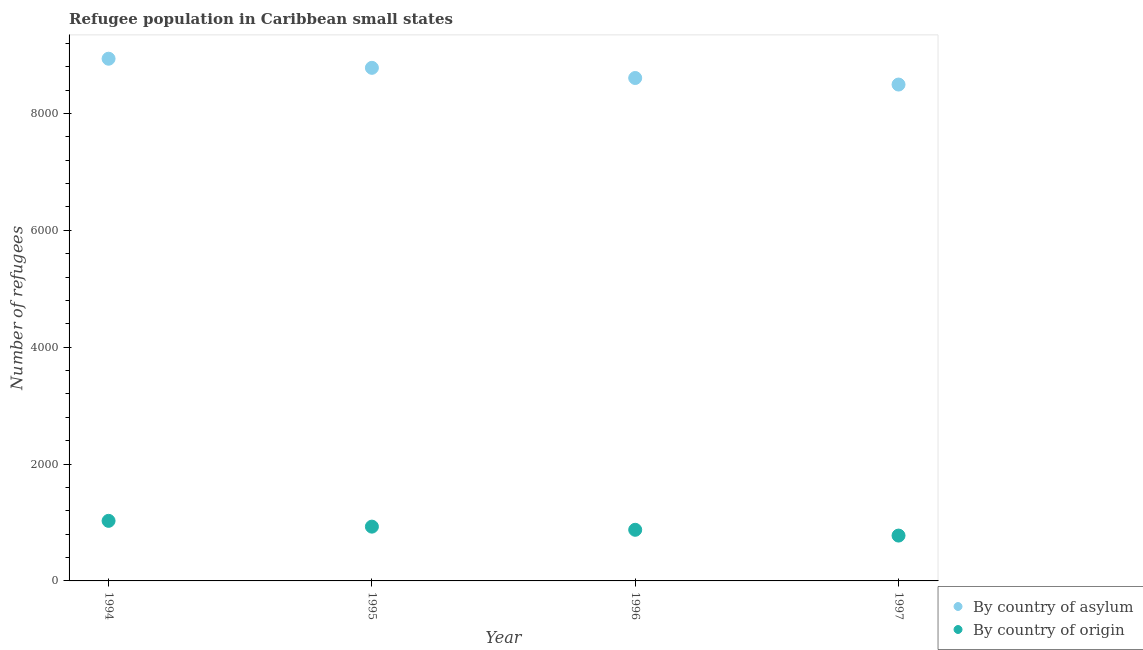What is the number of refugees by country of asylum in 1994?
Your answer should be very brief. 8937. Across all years, what is the maximum number of refugees by country of origin?
Your response must be concise. 1028. Across all years, what is the minimum number of refugees by country of asylum?
Offer a terse response. 8495. In which year was the number of refugees by country of asylum maximum?
Your answer should be very brief. 1994. What is the total number of refugees by country of asylum in the graph?
Provide a short and direct response. 3.48e+04. What is the difference between the number of refugees by country of origin in 1994 and that in 1997?
Give a very brief answer. 252. What is the difference between the number of refugees by country of asylum in 1996 and the number of refugees by country of origin in 1995?
Provide a succinct answer. 7678. What is the average number of refugees by country of asylum per year?
Offer a terse response. 8705. In the year 1994, what is the difference between the number of refugees by country of origin and number of refugees by country of asylum?
Offer a very short reply. -7909. In how many years, is the number of refugees by country of asylum greater than 4000?
Offer a terse response. 4. What is the ratio of the number of refugees by country of origin in 1994 to that in 1995?
Offer a very short reply. 1.11. Is the number of refugees by country of asylum in 1995 less than that in 1997?
Your response must be concise. No. Is the difference between the number of refugees by country of origin in 1994 and 1996 greater than the difference between the number of refugees by country of asylum in 1994 and 1996?
Your answer should be compact. No. What is the difference between the highest and the lowest number of refugees by country of origin?
Your answer should be very brief. 252. In how many years, is the number of refugees by country of origin greater than the average number of refugees by country of origin taken over all years?
Keep it short and to the point. 2. Is the number of refugees by country of origin strictly less than the number of refugees by country of asylum over the years?
Provide a succinct answer. Yes. How many years are there in the graph?
Your answer should be compact. 4. What is the difference between two consecutive major ticks on the Y-axis?
Your answer should be compact. 2000. Does the graph contain grids?
Your response must be concise. No. Where does the legend appear in the graph?
Give a very brief answer. Bottom right. What is the title of the graph?
Provide a short and direct response. Refugee population in Caribbean small states. What is the label or title of the Y-axis?
Offer a terse response. Number of refugees. What is the Number of refugees in By country of asylum in 1994?
Provide a short and direct response. 8937. What is the Number of refugees in By country of origin in 1994?
Your response must be concise. 1028. What is the Number of refugees of By country of asylum in 1995?
Keep it short and to the point. 8781. What is the Number of refugees in By country of origin in 1995?
Give a very brief answer. 929. What is the Number of refugees of By country of asylum in 1996?
Provide a succinct answer. 8607. What is the Number of refugees of By country of origin in 1996?
Ensure brevity in your answer.  875. What is the Number of refugees in By country of asylum in 1997?
Ensure brevity in your answer.  8495. What is the Number of refugees of By country of origin in 1997?
Your answer should be compact. 776. Across all years, what is the maximum Number of refugees of By country of asylum?
Your response must be concise. 8937. Across all years, what is the maximum Number of refugees of By country of origin?
Ensure brevity in your answer.  1028. Across all years, what is the minimum Number of refugees of By country of asylum?
Give a very brief answer. 8495. Across all years, what is the minimum Number of refugees in By country of origin?
Your answer should be very brief. 776. What is the total Number of refugees of By country of asylum in the graph?
Make the answer very short. 3.48e+04. What is the total Number of refugees of By country of origin in the graph?
Give a very brief answer. 3608. What is the difference between the Number of refugees of By country of asylum in 1994 and that in 1995?
Your answer should be compact. 156. What is the difference between the Number of refugees in By country of origin in 1994 and that in 1995?
Ensure brevity in your answer.  99. What is the difference between the Number of refugees of By country of asylum in 1994 and that in 1996?
Offer a very short reply. 330. What is the difference between the Number of refugees of By country of origin in 1994 and that in 1996?
Provide a short and direct response. 153. What is the difference between the Number of refugees of By country of asylum in 1994 and that in 1997?
Make the answer very short. 442. What is the difference between the Number of refugees in By country of origin in 1994 and that in 1997?
Make the answer very short. 252. What is the difference between the Number of refugees of By country of asylum in 1995 and that in 1996?
Make the answer very short. 174. What is the difference between the Number of refugees of By country of asylum in 1995 and that in 1997?
Your response must be concise. 286. What is the difference between the Number of refugees in By country of origin in 1995 and that in 1997?
Provide a short and direct response. 153. What is the difference between the Number of refugees of By country of asylum in 1996 and that in 1997?
Provide a short and direct response. 112. What is the difference between the Number of refugees of By country of origin in 1996 and that in 1997?
Offer a terse response. 99. What is the difference between the Number of refugees of By country of asylum in 1994 and the Number of refugees of By country of origin in 1995?
Give a very brief answer. 8008. What is the difference between the Number of refugees in By country of asylum in 1994 and the Number of refugees in By country of origin in 1996?
Ensure brevity in your answer.  8062. What is the difference between the Number of refugees of By country of asylum in 1994 and the Number of refugees of By country of origin in 1997?
Make the answer very short. 8161. What is the difference between the Number of refugees in By country of asylum in 1995 and the Number of refugees in By country of origin in 1996?
Your response must be concise. 7906. What is the difference between the Number of refugees of By country of asylum in 1995 and the Number of refugees of By country of origin in 1997?
Ensure brevity in your answer.  8005. What is the difference between the Number of refugees in By country of asylum in 1996 and the Number of refugees in By country of origin in 1997?
Keep it short and to the point. 7831. What is the average Number of refugees in By country of asylum per year?
Ensure brevity in your answer.  8705. What is the average Number of refugees in By country of origin per year?
Make the answer very short. 902. In the year 1994, what is the difference between the Number of refugees in By country of asylum and Number of refugees in By country of origin?
Provide a short and direct response. 7909. In the year 1995, what is the difference between the Number of refugees in By country of asylum and Number of refugees in By country of origin?
Your answer should be very brief. 7852. In the year 1996, what is the difference between the Number of refugees in By country of asylum and Number of refugees in By country of origin?
Provide a succinct answer. 7732. In the year 1997, what is the difference between the Number of refugees of By country of asylum and Number of refugees of By country of origin?
Keep it short and to the point. 7719. What is the ratio of the Number of refugees in By country of asylum in 1994 to that in 1995?
Keep it short and to the point. 1.02. What is the ratio of the Number of refugees of By country of origin in 1994 to that in 1995?
Provide a short and direct response. 1.11. What is the ratio of the Number of refugees in By country of asylum in 1994 to that in 1996?
Your answer should be very brief. 1.04. What is the ratio of the Number of refugees of By country of origin in 1994 to that in 1996?
Offer a very short reply. 1.17. What is the ratio of the Number of refugees of By country of asylum in 1994 to that in 1997?
Offer a very short reply. 1.05. What is the ratio of the Number of refugees of By country of origin in 1994 to that in 1997?
Keep it short and to the point. 1.32. What is the ratio of the Number of refugees of By country of asylum in 1995 to that in 1996?
Keep it short and to the point. 1.02. What is the ratio of the Number of refugees in By country of origin in 1995 to that in 1996?
Your response must be concise. 1.06. What is the ratio of the Number of refugees of By country of asylum in 1995 to that in 1997?
Your answer should be very brief. 1.03. What is the ratio of the Number of refugees in By country of origin in 1995 to that in 1997?
Keep it short and to the point. 1.2. What is the ratio of the Number of refugees of By country of asylum in 1996 to that in 1997?
Provide a short and direct response. 1.01. What is the ratio of the Number of refugees in By country of origin in 1996 to that in 1997?
Keep it short and to the point. 1.13. What is the difference between the highest and the second highest Number of refugees of By country of asylum?
Make the answer very short. 156. What is the difference between the highest and the second highest Number of refugees of By country of origin?
Ensure brevity in your answer.  99. What is the difference between the highest and the lowest Number of refugees in By country of asylum?
Give a very brief answer. 442. What is the difference between the highest and the lowest Number of refugees in By country of origin?
Your response must be concise. 252. 